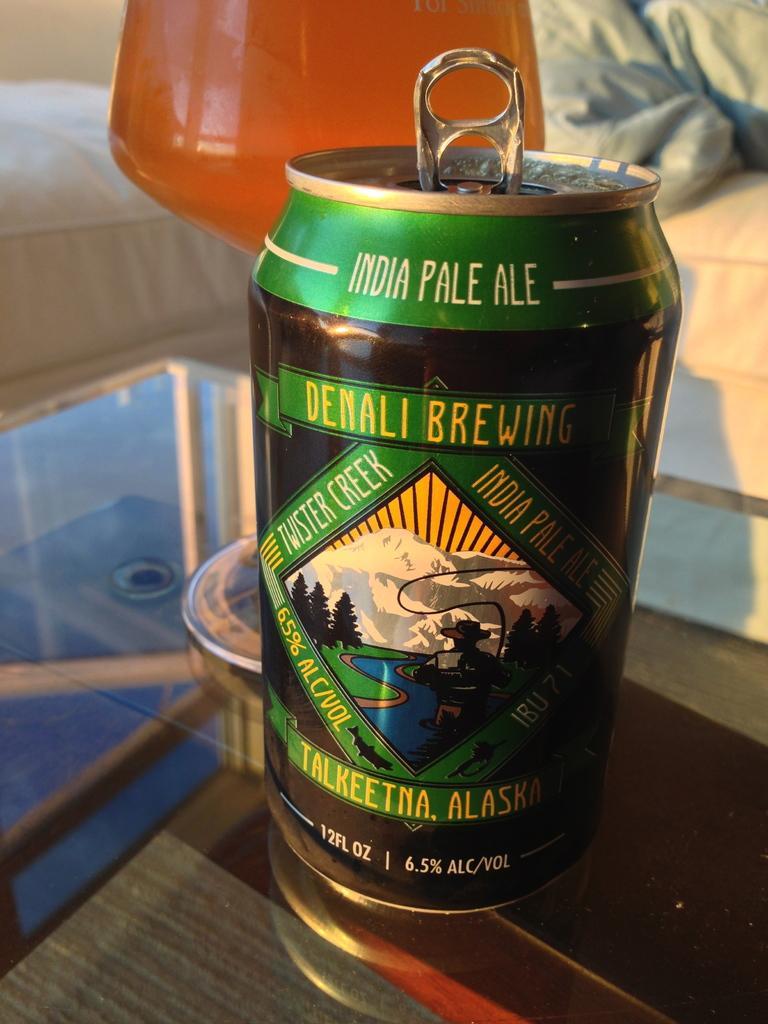Please provide a concise description of this image. In this image we can see a tin and a glass with some liquid on the table, in the background it looks like the sofa. 